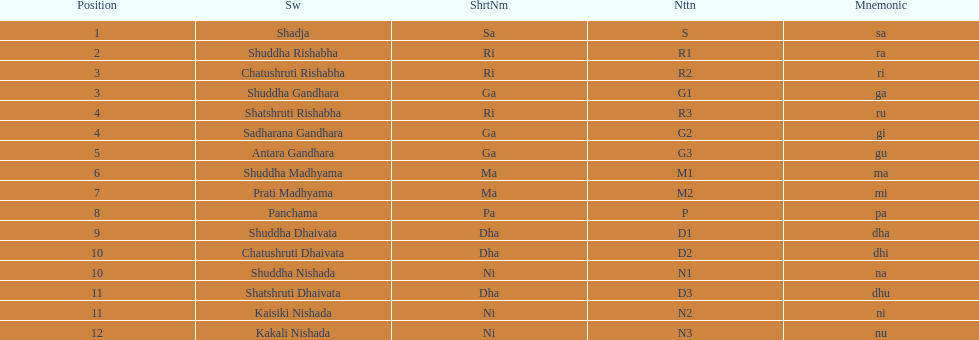Other than m1 how many notations have "1" in them? 4. 